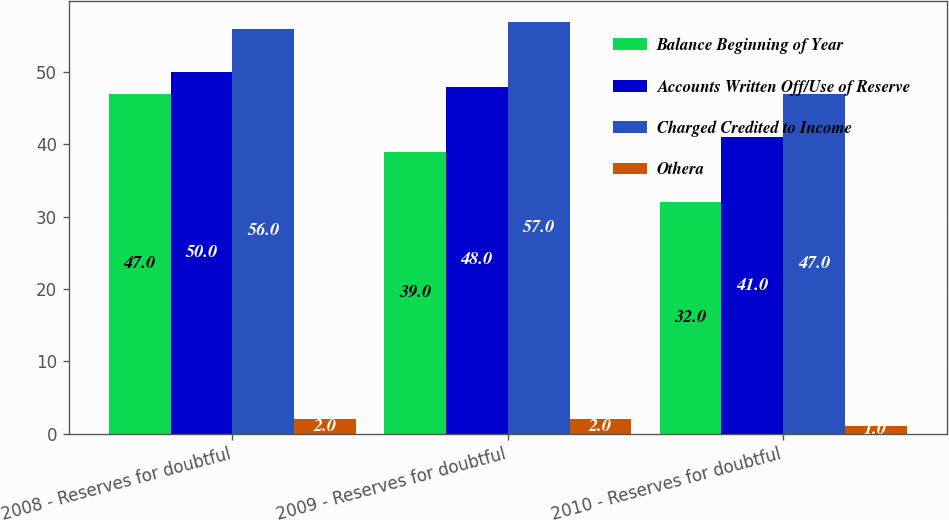Convert chart. <chart><loc_0><loc_0><loc_500><loc_500><stacked_bar_chart><ecel><fcel>2008 - Reserves for doubtful<fcel>2009 - Reserves for doubtful<fcel>2010 - Reserves for doubtful<nl><fcel>Balance Beginning of Year<fcel>47<fcel>39<fcel>32<nl><fcel>Accounts Written Off/Use of Reserve<fcel>50<fcel>48<fcel>41<nl><fcel>Charged Credited to Income<fcel>56<fcel>57<fcel>47<nl><fcel>Othera<fcel>2<fcel>2<fcel>1<nl></chart> 